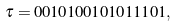<formula> <loc_0><loc_0><loc_500><loc_500>\tau = 0 0 1 0 1 0 0 1 0 1 0 1 1 1 0 1 ,</formula> 